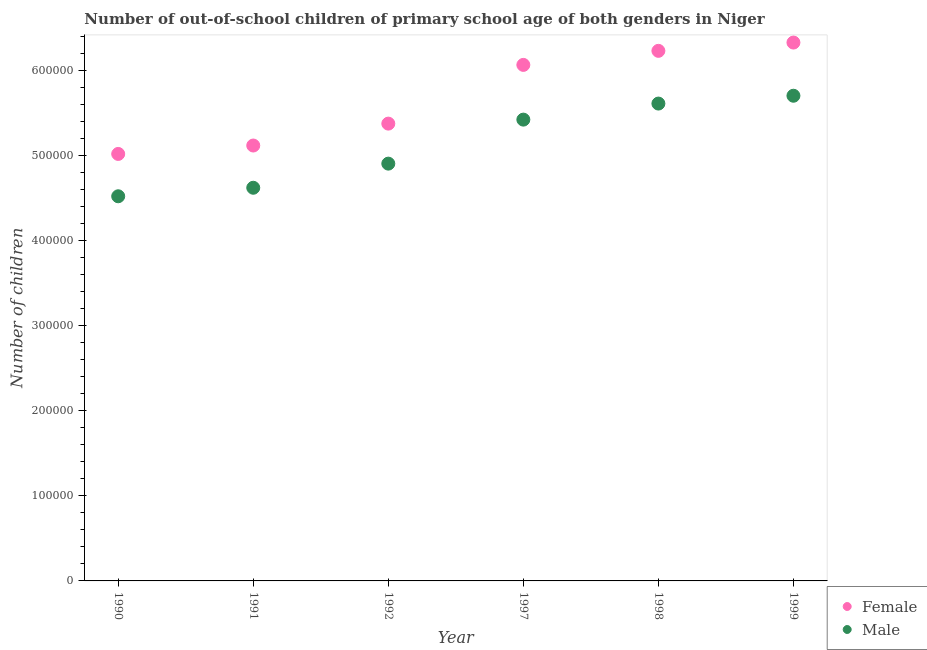Is the number of dotlines equal to the number of legend labels?
Give a very brief answer. Yes. What is the number of female out-of-school students in 1997?
Give a very brief answer. 6.07e+05. Across all years, what is the maximum number of female out-of-school students?
Ensure brevity in your answer.  6.33e+05. Across all years, what is the minimum number of male out-of-school students?
Offer a very short reply. 4.52e+05. In which year was the number of female out-of-school students maximum?
Offer a terse response. 1999. In which year was the number of female out-of-school students minimum?
Provide a succinct answer. 1990. What is the total number of female out-of-school students in the graph?
Provide a succinct answer. 3.41e+06. What is the difference between the number of male out-of-school students in 1990 and that in 1997?
Your response must be concise. -9.01e+04. What is the difference between the number of female out-of-school students in 1990 and the number of male out-of-school students in 1998?
Offer a very short reply. -5.92e+04. What is the average number of male out-of-school students per year?
Provide a short and direct response. 5.13e+05. In the year 1992, what is the difference between the number of female out-of-school students and number of male out-of-school students?
Give a very brief answer. 4.70e+04. In how many years, is the number of female out-of-school students greater than 360000?
Your answer should be very brief. 6. What is the ratio of the number of male out-of-school students in 1991 to that in 1997?
Provide a succinct answer. 0.85. Is the number of male out-of-school students in 1990 less than that in 1992?
Offer a very short reply. Yes. Is the difference between the number of male out-of-school students in 1990 and 1997 greater than the difference between the number of female out-of-school students in 1990 and 1997?
Keep it short and to the point. Yes. What is the difference between the highest and the second highest number of female out-of-school students?
Make the answer very short. 9742. What is the difference between the highest and the lowest number of male out-of-school students?
Give a very brief answer. 1.18e+05. Does the number of male out-of-school students monotonically increase over the years?
Offer a terse response. Yes. Is the number of female out-of-school students strictly less than the number of male out-of-school students over the years?
Offer a terse response. No. What is the difference between two consecutive major ticks on the Y-axis?
Your answer should be compact. 1.00e+05. Does the graph contain any zero values?
Your answer should be compact. No. Does the graph contain grids?
Provide a succinct answer. No. How many legend labels are there?
Provide a succinct answer. 2. How are the legend labels stacked?
Offer a terse response. Vertical. What is the title of the graph?
Make the answer very short. Number of out-of-school children of primary school age of both genders in Niger. What is the label or title of the X-axis?
Your answer should be very brief. Year. What is the label or title of the Y-axis?
Your answer should be very brief. Number of children. What is the Number of children of Female in 1990?
Offer a terse response. 5.02e+05. What is the Number of children of Male in 1990?
Your response must be concise. 4.52e+05. What is the Number of children of Female in 1991?
Offer a very short reply. 5.12e+05. What is the Number of children of Male in 1991?
Offer a very short reply. 4.62e+05. What is the Number of children in Female in 1992?
Your response must be concise. 5.38e+05. What is the Number of children of Male in 1992?
Offer a very short reply. 4.91e+05. What is the Number of children of Female in 1997?
Make the answer very short. 6.07e+05. What is the Number of children of Male in 1997?
Ensure brevity in your answer.  5.42e+05. What is the Number of children of Female in 1998?
Ensure brevity in your answer.  6.23e+05. What is the Number of children in Male in 1998?
Keep it short and to the point. 5.61e+05. What is the Number of children of Female in 1999?
Keep it short and to the point. 6.33e+05. What is the Number of children of Male in 1999?
Offer a very short reply. 5.70e+05. Across all years, what is the maximum Number of children of Female?
Your answer should be compact. 6.33e+05. Across all years, what is the maximum Number of children in Male?
Provide a short and direct response. 5.70e+05. Across all years, what is the minimum Number of children of Female?
Keep it short and to the point. 5.02e+05. Across all years, what is the minimum Number of children in Male?
Keep it short and to the point. 4.52e+05. What is the total Number of children in Female in the graph?
Offer a terse response. 3.41e+06. What is the total Number of children of Male in the graph?
Give a very brief answer. 3.08e+06. What is the difference between the Number of children in Female in 1990 and that in 1991?
Your answer should be compact. -9885. What is the difference between the Number of children of Male in 1990 and that in 1991?
Ensure brevity in your answer.  -1.00e+04. What is the difference between the Number of children in Female in 1990 and that in 1992?
Make the answer very short. -3.56e+04. What is the difference between the Number of children in Male in 1990 and that in 1992?
Keep it short and to the point. -3.84e+04. What is the difference between the Number of children of Female in 1990 and that in 1997?
Provide a succinct answer. -1.05e+05. What is the difference between the Number of children in Male in 1990 and that in 1997?
Provide a short and direct response. -9.01e+04. What is the difference between the Number of children of Female in 1990 and that in 1998?
Offer a very short reply. -1.21e+05. What is the difference between the Number of children in Male in 1990 and that in 1998?
Give a very brief answer. -1.09e+05. What is the difference between the Number of children of Female in 1990 and that in 1999?
Your answer should be compact. -1.31e+05. What is the difference between the Number of children of Male in 1990 and that in 1999?
Make the answer very short. -1.18e+05. What is the difference between the Number of children of Female in 1991 and that in 1992?
Give a very brief answer. -2.57e+04. What is the difference between the Number of children of Male in 1991 and that in 1992?
Ensure brevity in your answer.  -2.84e+04. What is the difference between the Number of children in Female in 1991 and that in 1997?
Offer a very short reply. -9.48e+04. What is the difference between the Number of children in Male in 1991 and that in 1997?
Keep it short and to the point. -8.01e+04. What is the difference between the Number of children of Female in 1991 and that in 1998?
Provide a succinct answer. -1.11e+05. What is the difference between the Number of children in Male in 1991 and that in 1998?
Provide a short and direct response. -9.90e+04. What is the difference between the Number of children in Female in 1991 and that in 1999?
Provide a succinct answer. -1.21e+05. What is the difference between the Number of children of Male in 1991 and that in 1999?
Make the answer very short. -1.08e+05. What is the difference between the Number of children in Female in 1992 and that in 1997?
Ensure brevity in your answer.  -6.90e+04. What is the difference between the Number of children in Male in 1992 and that in 1997?
Keep it short and to the point. -5.17e+04. What is the difference between the Number of children in Female in 1992 and that in 1998?
Offer a very short reply. -8.55e+04. What is the difference between the Number of children in Male in 1992 and that in 1998?
Your response must be concise. -7.06e+04. What is the difference between the Number of children in Female in 1992 and that in 1999?
Your response must be concise. -9.53e+04. What is the difference between the Number of children of Male in 1992 and that in 1999?
Offer a very short reply. -7.98e+04. What is the difference between the Number of children in Female in 1997 and that in 1998?
Make the answer very short. -1.65e+04. What is the difference between the Number of children of Male in 1997 and that in 1998?
Your answer should be compact. -1.89e+04. What is the difference between the Number of children of Female in 1997 and that in 1999?
Offer a terse response. -2.63e+04. What is the difference between the Number of children in Male in 1997 and that in 1999?
Provide a short and direct response. -2.81e+04. What is the difference between the Number of children in Female in 1998 and that in 1999?
Provide a short and direct response. -9742. What is the difference between the Number of children of Male in 1998 and that in 1999?
Your answer should be compact. -9198. What is the difference between the Number of children in Female in 1990 and the Number of children in Male in 1991?
Your response must be concise. 3.98e+04. What is the difference between the Number of children of Female in 1990 and the Number of children of Male in 1992?
Make the answer very short. 1.14e+04. What is the difference between the Number of children of Female in 1990 and the Number of children of Male in 1997?
Ensure brevity in your answer.  -4.03e+04. What is the difference between the Number of children of Female in 1990 and the Number of children of Male in 1998?
Make the answer very short. -5.92e+04. What is the difference between the Number of children in Female in 1990 and the Number of children in Male in 1999?
Ensure brevity in your answer.  -6.84e+04. What is the difference between the Number of children in Female in 1991 and the Number of children in Male in 1992?
Your response must be concise. 2.13e+04. What is the difference between the Number of children of Female in 1991 and the Number of children of Male in 1997?
Give a very brief answer. -3.04e+04. What is the difference between the Number of children in Female in 1991 and the Number of children in Male in 1998?
Your answer should be very brief. -4.93e+04. What is the difference between the Number of children in Female in 1991 and the Number of children in Male in 1999?
Offer a terse response. -5.85e+04. What is the difference between the Number of children of Female in 1992 and the Number of children of Male in 1997?
Give a very brief answer. -4703. What is the difference between the Number of children of Female in 1992 and the Number of children of Male in 1998?
Your answer should be very brief. -2.36e+04. What is the difference between the Number of children in Female in 1992 and the Number of children in Male in 1999?
Your response must be concise. -3.28e+04. What is the difference between the Number of children of Female in 1997 and the Number of children of Male in 1998?
Provide a succinct answer. 4.55e+04. What is the difference between the Number of children in Female in 1997 and the Number of children in Male in 1999?
Provide a succinct answer. 3.63e+04. What is the difference between the Number of children in Female in 1998 and the Number of children in Male in 1999?
Make the answer very short. 5.28e+04. What is the average Number of children in Female per year?
Keep it short and to the point. 5.69e+05. What is the average Number of children in Male per year?
Provide a succinct answer. 5.13e+05. In the year 1990, what is the difference between the Number of children in Female and Number of children in Male?
Your response must be concise. 4.98e+04. In the year 1991, what is the difference between the Number of children of Female and Number of children of Male?
Provide a short and direct response. 4.96e+04. In the year 1992, what is the difference between the Number of children of Female and Number of children of Male?
Provide a succinct answer. 4.70e+04. In the year 1997, what is the difference between the Number of children in Female and Number of children in Male?
Ensure brevity in your answer.  6.43e+04. In the year 1998, what is the difference between the Number of children in Female and Number of children in Male?
Make the answer very short. 6.20e+04. In the year 1999, what is the difference between the Number of children of Female and Number of children of Male?
Your answer should be very brief. 6.25e+04. What is the ratio of the Number of children of Female in 1990 to that in 1991?
Your answer should be very brief. 0.98. What is the ratio of the Number of children of Male in 1990 to that in 1991?
Keep it short and to the point. 0.98. What is the ratio of the Number of children of Female in 1990 to that in 1992?
Ensure brevity in your answer.  0.93. What is the ratio of the Number of children of Male in 1990 to that in 1992?
Offer a very short reply. 0.92. What is the ratio of the Number of children of Female in 1990 to that in 1997?
Your answer should be very brief. 0.83. What is the ratio of the Number of children of Male in 1990 to that in 1997?
Provide a succinct answer. 0.83. What is the ratio of the Number of children of Female in 1990 to that in 1998?
Ensure brevity in your answer.  0.81. What is the ratio of the Number of children in Male in 1990 to that in 1998?
Provide a short and direct response. 0.81. What is the ratio of the Number of children of Female in 1990 to that in 1999?
Your answer should be compact. 0.79. What is the ratio of the Number of children in Male in 1990 to that in 1999?
Make the answer very short. 0.79. What is the ratio of the Number of children in Female in 1991 to that in 1992?
Keep it short and to the point. 0.95. What is the ratio of the Number of children in Male in 1991 to that in 1992?
Ensure brevity in your answer.  0.94. What is the ratio of the Number of children of Female in 1991 to that in 1997?
Make the answer very short. 0.84. What is the ratio of the Number of children in Male in 1991 to that in 1997?
Give a very brief answer. 0.85. What is the ratio of the Number of children of Female in 1991 to that in 1998?
Provide a short and direct response. 0.82. What is the ratio of the Number of children in Male in 1991 to that in 1998?
Offer a terse response. 0.82. What is the ratio of the Number of children in Female in 1991 to that in 1999?
Ensure brevity in your answer.  0.81. What is the ratio of the Number of children in Male in 1991 to that in 1999?
Your response must be concise. 0.81. What is the ratio of the Number of children in Female in 1992 to that in 1997?
Offer a very short reply. 0.89. What is the ratio of the Number of children in Male in 1992 to that in 1997?
Your response must be concise. 0.9. What is the ratio of the Number of children in Female in 1992 to that in 1998?
Give a very brief answer. 0.86. What is the ratio of the Number of children of Male in 1992 to that in 1998?
Offer a very short reply. 0.87. What is the ratio of the Number of children of Female in 1992 to that in 1999?
Your answer should be very brief. 0.85. What is the ratio of the Number of children of Male in 1992 to that in 1999?
Give a very brief answer. 0.86. What is the ratio of the Number of children of Female in 1997 to that in 1998?
Give a very brief answer. 0.97. What is the ratio of the Number of children in Male in 1997 to that in 1998?
Your answer should be compact. 0.97. What is the ratio of the Number of children of Female in 1997 to that in 1999?
Ensure brevity in your answer.  0.96. What is the ratio of the Number of children in Male in 1997 to that in 1999?
Your answer should be compact. 0.95. What is the ratio of the Number of children in Female in 1998 to that in 1999?
Your response must be concise. 0.98. What is the ratio of the Number of children in Male in 1998 to that in 1999?
Provide a succinct answer. 0.98. What is the difference between the highest and the second highest Number of children in Female?
Give a very brief answer. 9742. What is the difference between the highest and the second highest Number of children in Male?
Provide a short and direct response. 9198. What is the difference between the highest and the lowest Number of children of Female?
Provide a short and direct response. 1.31e+05. What is the difference between the highest and the lowest Number of children in Male?
Your answer should be compact. 1.18e+05. 